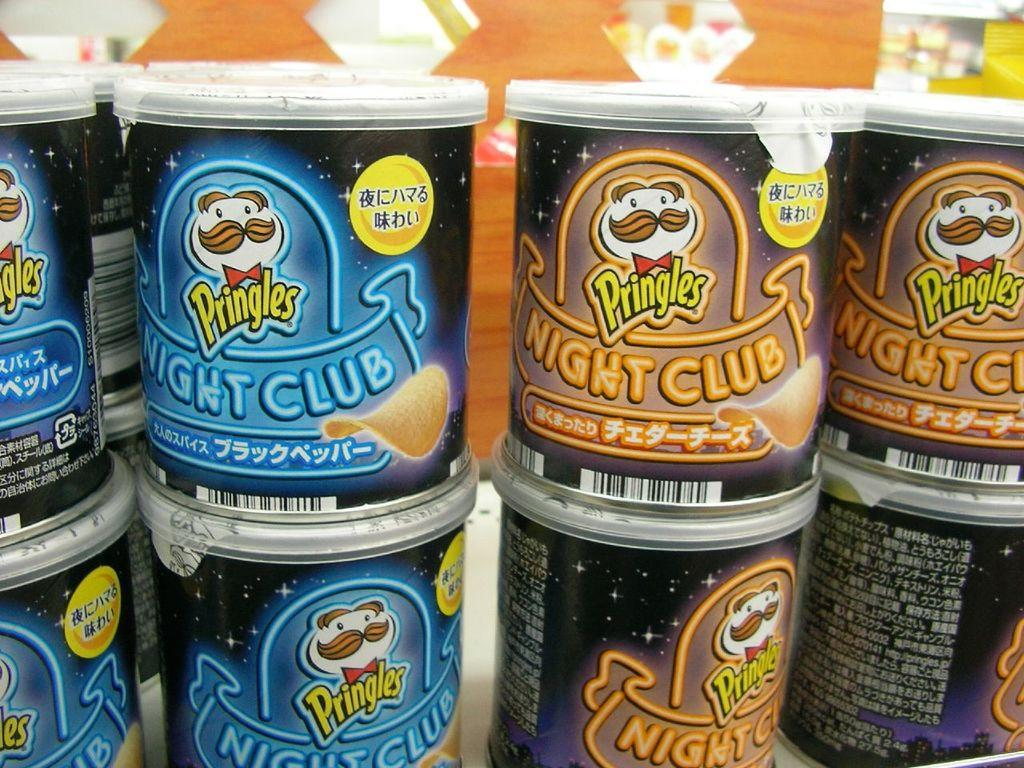What type of items are arranged in a row in the image? There are chip boxes in the image, arranged in a row. How many chip boxes can be seen in the image? The image shows a row of chip boxes, but the exact number is not specified. What might be the purpose of arranging the chip boxes in a row? The purpose of arranging the chip boxes in a row is not explicitly stated, but it could be for display, organization, or presentation. What type of attraction can be seen in the background of the image? There is no attraction visible in the image; it only shows a row of chip boxes. 